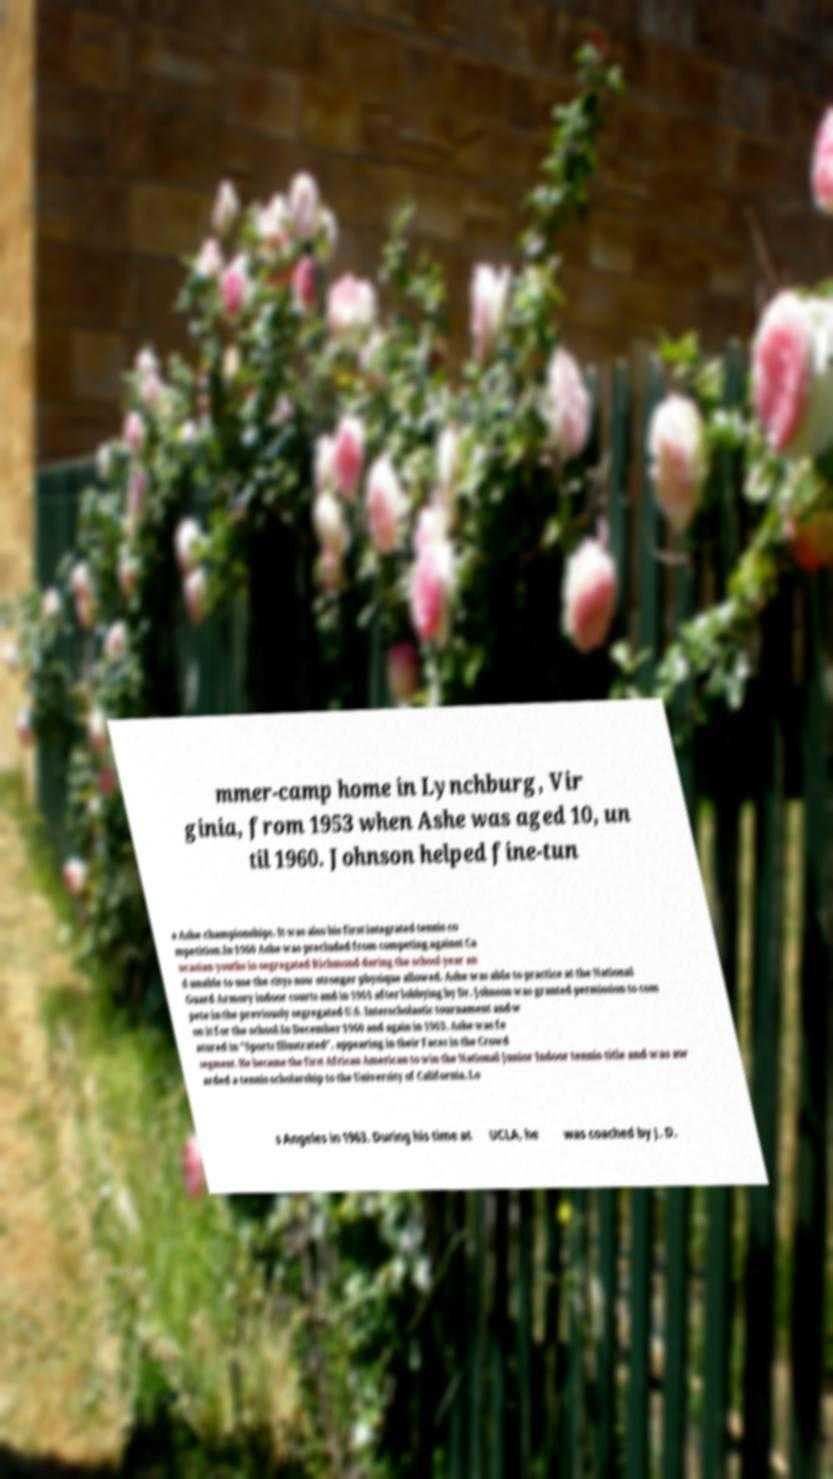Please read and relay the text visible in this image. What does it say? mmer-camp home in Lynchburg, Vir ginia, from 1953 when Ashe was aged 10, un til 1960. Johnson helped fine-tun e Ashe championships. It was also his first integrated tennis co mpetition.In 1960 Ashe was precluded from competing against Ca ucasian youths in segregated Richmond during the school year an d unable to use the citys now stronger physique allowed. Ashe was able to practice at the National Guard Armory indoor courts and in 1961 after lobbying by Dr. Johnson was granted permission to com pete in the previously segregated U.S. Interscholastic tournament and w on it for the school.In December 1960 and again in 1963, Ashe was fe atured in "Sports Illustrated", appearing in their Faces in the Crowd segment. He became the first African American to win the National Junior Indoor tennis title and was aw arded a tennis scholarship to the University of California, Lo s Angeles in 1963. During his time at UCLA, he was coached by J. D. 